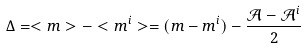<formula> <loc_0><loc_0><loc_500><loc_500>\Delta = < m > - < m ^ { i } > = ( m - m ^ { i } ) - \frac { \mathcal { A } - \mathcal { A } ^ { i } } { 2 }</formula> 